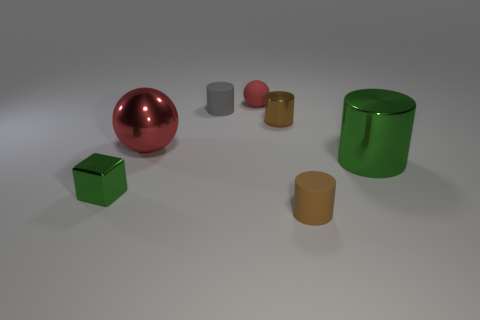Add 2 big purple spheres. How many objects exist? 9 Subtract all blocks. How many objects are left? 6 Add 6 small red shiny cylinders. How many small red shiny cylinders exist? 6 Subtract 0 blue cylinders. How many objects are left? 7 Subtract all green metallic objects. Subtract all gray objects. How many objects are left? 4 Add 4 tiny red objects. How many tiny red objects are left? 5 